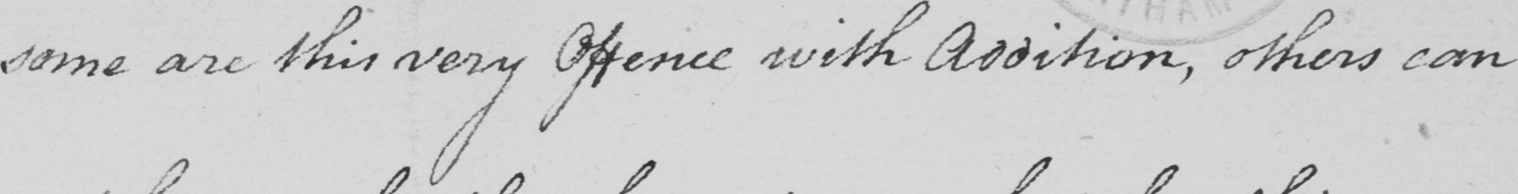What text is written in this handwritten line? some are this very Offence with Addition , others can 